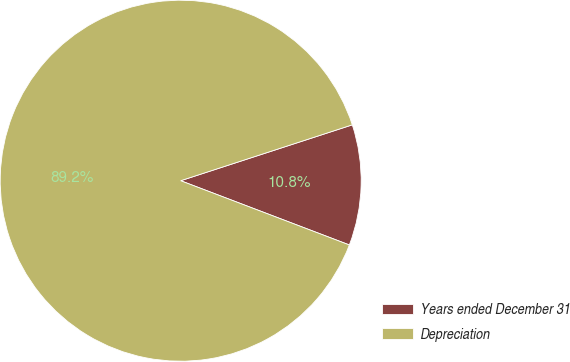Convert chart to OTSL. <chart><loc_0><loc_0><loc_500><loc_500><pie_chart><fcel>Years ended December 31<fcel>Depreciation<nl><fcel>10.8%<fcel>89.2%<nl></chart> 